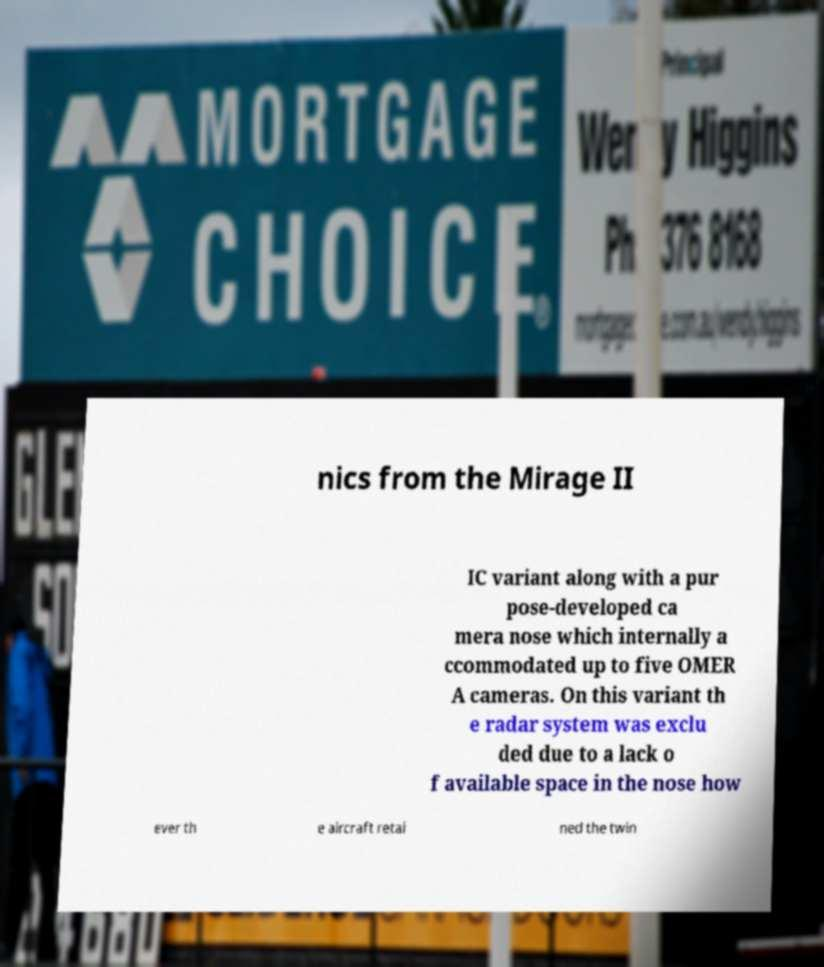Can you read and provide the text displayed in the image?This photo seems to have some interesting text. Can you extract and type it out for me? nics from the Mirage II IC variant along with a pur pose-developed ca mera nose which internally a ccommodated up to five OMER A cameras. On this variant th e radar system was exclu ded due to a lack o f available space in the nose how ever th e aircraft retai ned the twin 